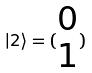<formula> <loc_0><loc_0><loc_500><loc_500>| 2 \rangle = ( \begin{matrix} 0 \\ 1 \end{matrix} )</formula> 